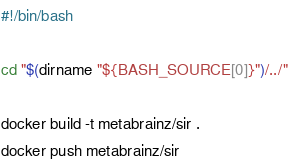<code> <loc_0><loc_0><loc_500><loc_500><_Bash_>#!/bin/bash

cd "$(dirname "${BASH_SOURCE[0]}")/../"

docker build -t metabrainz/sir .
docker push metabrainz/sir
</code> 